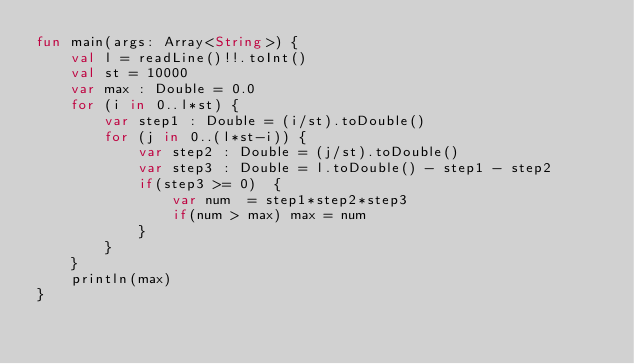Convert code to text. <code><loc_0><loc_0><loc_500><loc_500><_Kotlin_>fun main(args: Array<String>) {
    val l = readLine()!!.toInt()
    val st = 10000
    var max : Double = 0.0
    for (i in 0..l*st) {
        var step1 : Double = (i/st).toDouble()
        for (j in 0..(l*st-i)) {
            var step2 : Double = (j/st).toDouble()
            var step3 : Double = l.toDouble() - step1 - step2
            if(step3 >= 0)  {
                var num  = step1*step2*step3
                if(num > max) max = num
            }
        }
    }
    println(max)
}</code> 